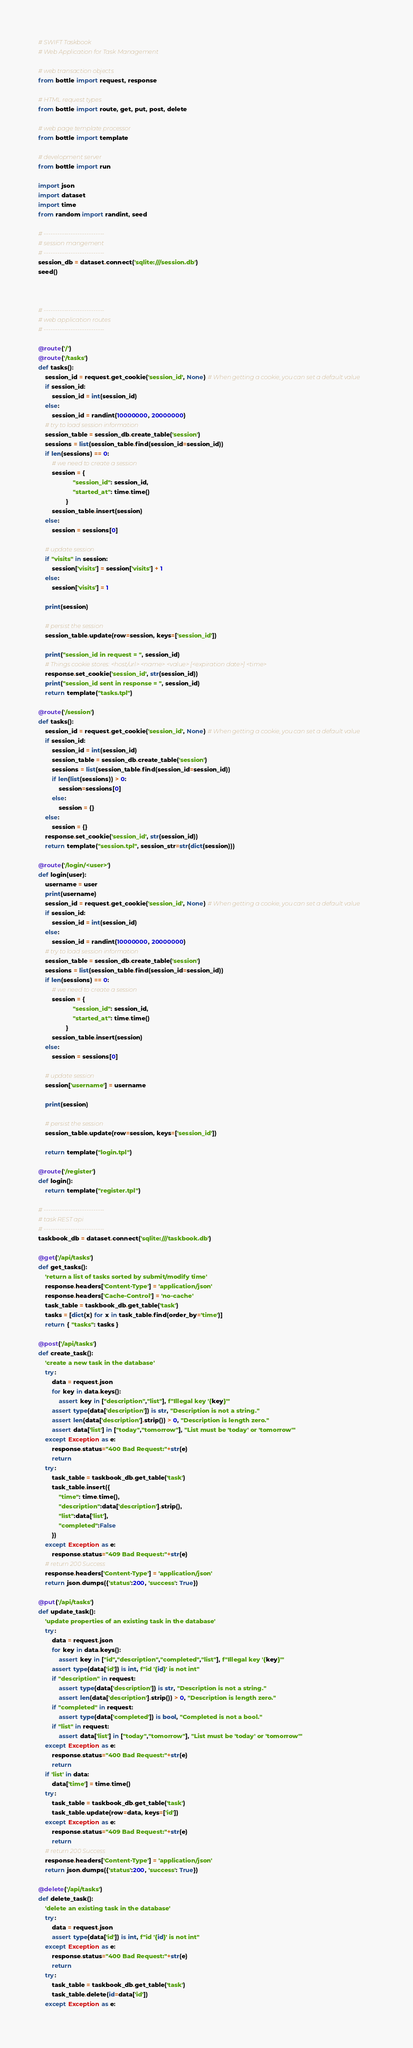<code> <loc_0><loc_0><loc_500><loc_500><_Python_># SWIFT Taskbook
# Web Application for Task Management 

# web transaction objects
from bottle import request, response

# HTML request types
from bottle import route, get, put, post, delete

# web page template processor
from bottle import template

# development server
from bottle import run 

import json
import dataset
import time
from random import randint, seed

# ---------------------------
# session mangement 
# ---------------------------
session_db = dataset.connect('sqlite:///session.db')
seed()



# ---------------------------
# web application routes
# ---------------------------

@route('/')
@route('/tasks')
def tasks():
    session_id = request.get_cookie('session_id', None) # When getting a cookie, you can set a default value
    if session_id:
        session_id = int(session_id)
    else:
        session_id = randint(10000000, 20000000)
    # try to load session information
    session_table = session_db.create_table('session')
    sessions = list(session_table.find(session_id=session_id))
    if len(sessions) == 0:
        # we need to create a session
        session = {
                    "session_id": session_id,
                    "started_at": time.time()
                }
        session_table.insert(session)
    else:
        session = sessions[0]
    
    # update session
    if "visits" in session:
        session['visits'] = session['visits'] + 1
    else:
        session['visits'] = 1

    print(session)

    # persist the session
    session_table.update(row=session, keys=['session_id'])

    print("session_id in request = ", session_id)
    # Things cookie stores: <host/url> <name> <value> [<expiration date>] <time>
    response.set_cookie('session_id', str(session_id))
    print("session_id sent in response = ", session_id)
    return template("tasks.tpl")

@route('/session')
def tasks():
    session_id = request.get_cookie('session_id', None) # When getting a cookie, you can set a default value
    if session_id:
        session_id = int(session_id)
        session_table = session_db.create_table('session')
        sessions = list(session_table.find(session_id=session_id))
        if len(list(sessions)) > 0:
            session=sessions[0]
        else:
            session = {}
    else:
        session = {}
    response.set_cookie('session_id', str(session_id))
    return template("session.tpl", session_str=str(dict(session)))

@route('/login/<user>')
def login(user):
    username = user
    print(username)
    session_id = request.get_cookie('session_id', None) # When getting a cookie, you can set a default value
    if session_id:
        session_id = int(session_id)
    else:
        session_id = randint(10000000, 20000000)
    # try to load session information
    session_table = session_db.create_table('session')
    sessions = list(session_table.find(session_id=session_id))
    if len(sessions) == 0:
        # we need to create a session
        session = {
                    "session_id": session_id,
                    "started_at": time.time()
                }
        session_table.insert(session)
    else:
        session = sessions[0]
    
    # update session
    session['username'] = username

    print(session)

    # persist the session
    session_table.update(row=session, keys=['session_id'])

    return template("login.tpl") 

@route('/register')
def login():
    return template("register.tpl") 

# ---------------------------
# task REST api 
# ---------------------------
taskbook_db = dataset.connect('sqlite:///taskbook.db')  

@get('/api/tasks')
def get_tasks():
    'return a list of tasks sorted by submit/modify time'
    response.headers['Content-Type'] = 'application/json'
    response.headers['Cache-Control'] = 'no-cache'
    task_table = taskbook_db.get_table('task')
    tasks = [dict(x) for x in task_table.find(order_by='time')]
    return { "tasks": tasks }

@post('/api/tasks')
def create_task():
    'create a new task in the database'
    try:
        data = request.json
        for key in data.keys():
            assert key in ["description","list"], f"Illegal key '{key}'"
        assert type(data['description']) is str, "Description is not a string."
        assert len(data['description'].strip()) > 0, "Description is length zero."
        assert data['list'] in ["today","tomorrow"], "List must be 'today' or 'tomorrow'"
    except Exception as e:
        response.status="400 Bad Request:"+str(e)
        return
    try:
        task_table = taskbook_db.get_table('task')
        task_table.insert({
            "time": time.time(),
            "description":data['description'].strip(),
            "list":data['list'],
            "completed":False
        })
    except Exception as e:
        response.status="409 Bad Request:"+str(e)
    # return 200 Success
    response.headers['Content-Type'] = 'application/json'
    return json.dumps({'status':200, 'success': True})

@put('/api/tasks')
def update_task():
    'update properties of an existing task in the database'
    try:
        data = request.json
        for key in data.keys():
            assert key in ["id","description","completed","list"], f"Illegal key '{key}'"
        assert type(data['id']) is int, f"id '{id}' is not int"
        if "description" in request:
            assert type(data['description']) is str, "Description is not a string."
            assert len(data['description'].strip()) > 0, "Description is length zero."
        if "completed" in request:
            assert type(data['completed']) is bool, "Completed is not a bool."
        if "list" in request:
            assert data['list'] in ["today","tomorrow"], "List must be 'today' or 'tomorrow'"
    except Exception as e:
        response.status="400 Bad Request:"+str(e)
        return
    if 'list' in data: 
        data['time'] = time.time()
    try:
        task_table = taskbook_db.get_table('task')
        task_table.update(row=data, keys=['id'])
    except Exception as e:
        response.status="409 Bad Request:"+str(e)
        return
    # return 200 Success
    response.headers['Content-Type'] = 'application/json'
    return json.dumps({'status':200, 'success': True})

@delete('/api/tasks')
def delete_task():
    'delete an existing task in the database'
    try:
        data = request.json
        assert type(data['id']) is int, f"id '{id}' is not int"
    except Exception as e:
        response.status="400 Bad Request:"+str(e)
        return
    try:
        task_table = taskbook_db.get_table('task')
        task_table.delete(id=data['id'])
    except Exception as e:</code> 